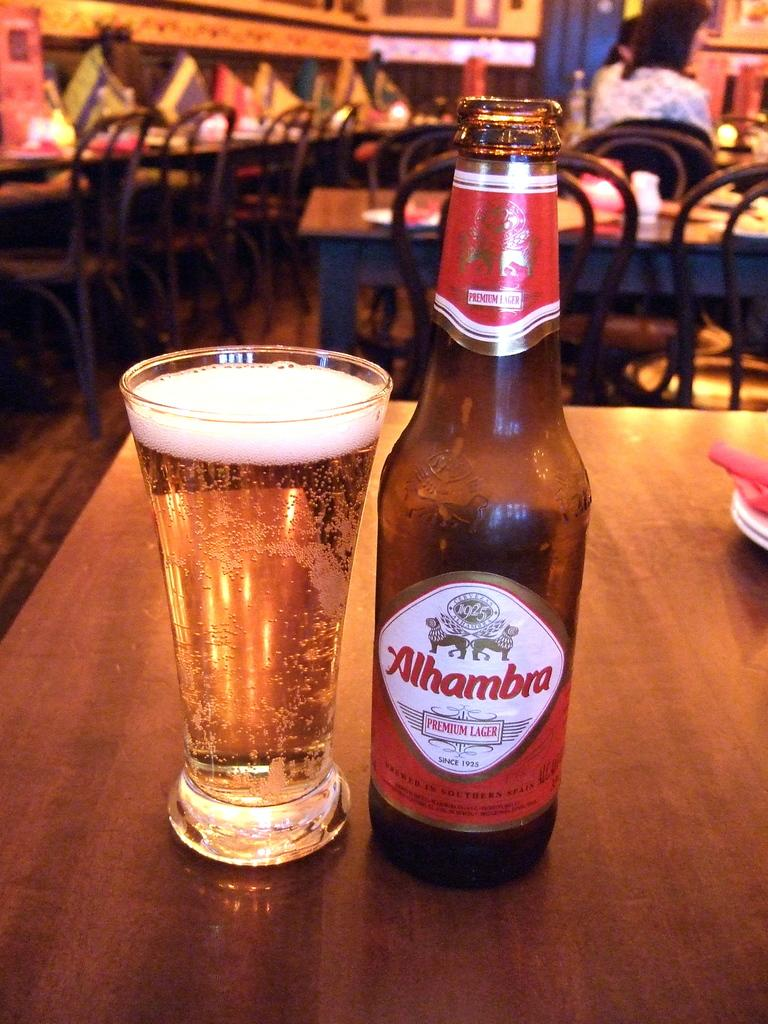<image>
Summarize the visual content of the image. a bottle of alhambra pemium lager standing next to a glass of it on a counter 